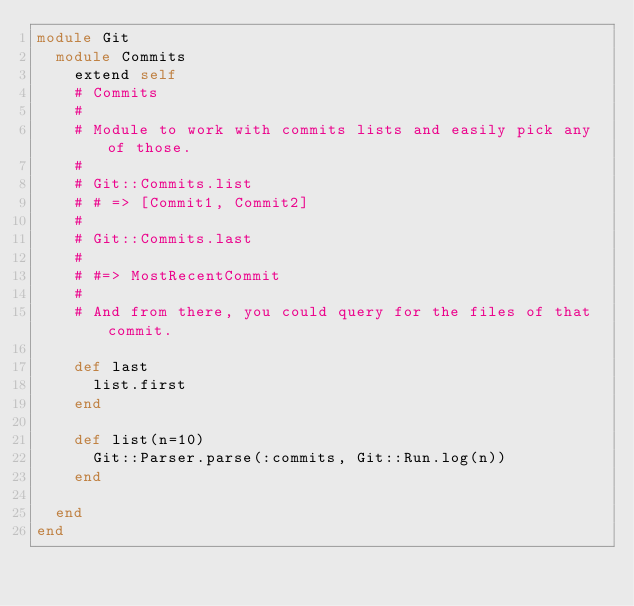Convert code to text. <code><loc_0><loc_0><loc_500><loc_500><_Ruby_>module Git
  module Commits
    extend self
    # Commits
    #
    # Module to work with commits lists and easily pick any of those.
    #
    # Git::Commits.list
    # # => [Commit1, Commit2]
    #
    # Git::Commits.last
    #
    # #=> MostRecentCommit
    #
    # And from there, you could query for the files of that commit.

    def last
      list.first
    end

    def list(n=10)
      Git::Parser.parse(:commits, Git::Run.log(n))
    end

  end
end
</code> 